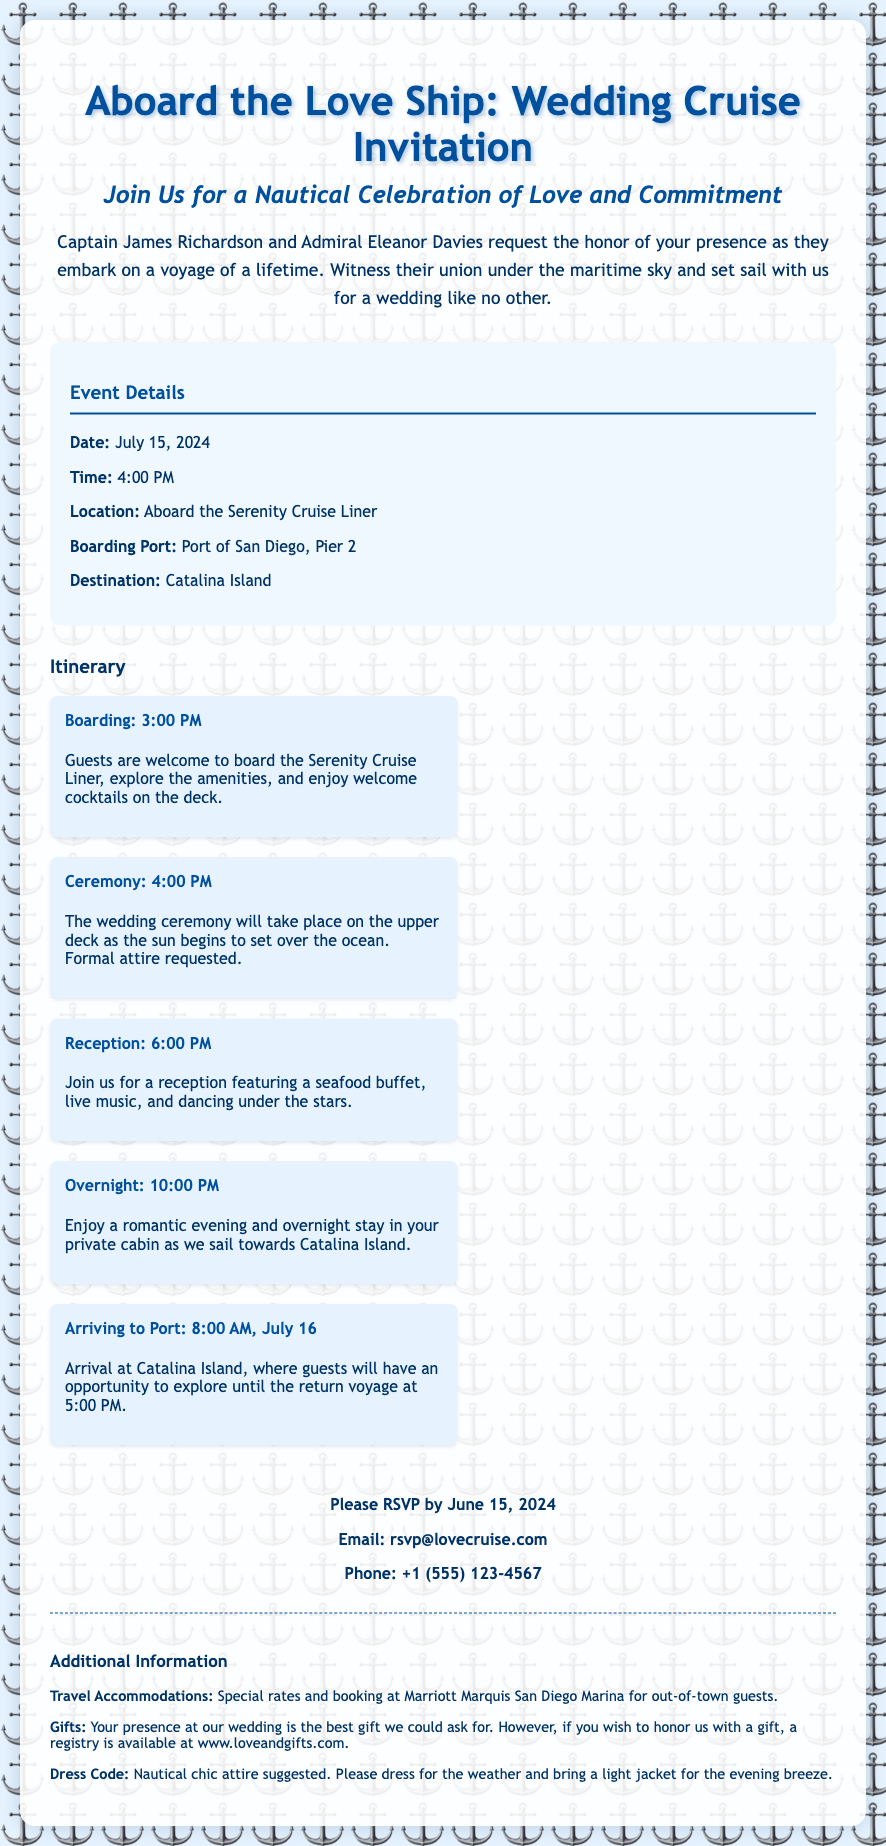What is the date of the wedding cruise? The wedding cruise is scheduled for July 15, 2024.
Answer: July 15, 2024 What time does the ceremony start? The ceremony begins at 4:00 PM as listed in the document.
Answer: 4:00 PM Who are the hosts of the wedding? The invitation lists Captain James Richardson and Admiral Eleanor Davies as the hosts.
Answer: Captain James Richardson and Admiral Eleanor Davies What is the location of the boarding? The boarding location is stated as Port of San Diego, Pier 2.
Answer: Port of San Diego, Pier 2 How long will the guests stay on the ship overnight? Guests will enjoy an overnight stay as the ship sails toward Catalina Island. This indicates they will stay for approximately one night.
Answer: Overnight What is the dress code suggested for the event? The dress code suggested is described as nautical chic attire.
Answer: Nautical chic What is the RSVP deadline? Guests are asked to RSVP by June 15, 2024.
Answer: June 15, 2024 What can guests expect at the reception? The reception will feature a seafood buffet, live music, and dancing.
Answer: Seafood buffet, live music, and dancing What accommodation is suggested for out-of-town guests? The document specifies special rates and booking at Marriott Marquis San Diego Marina.
Answer: Marriott Marquis San Diego Marina 